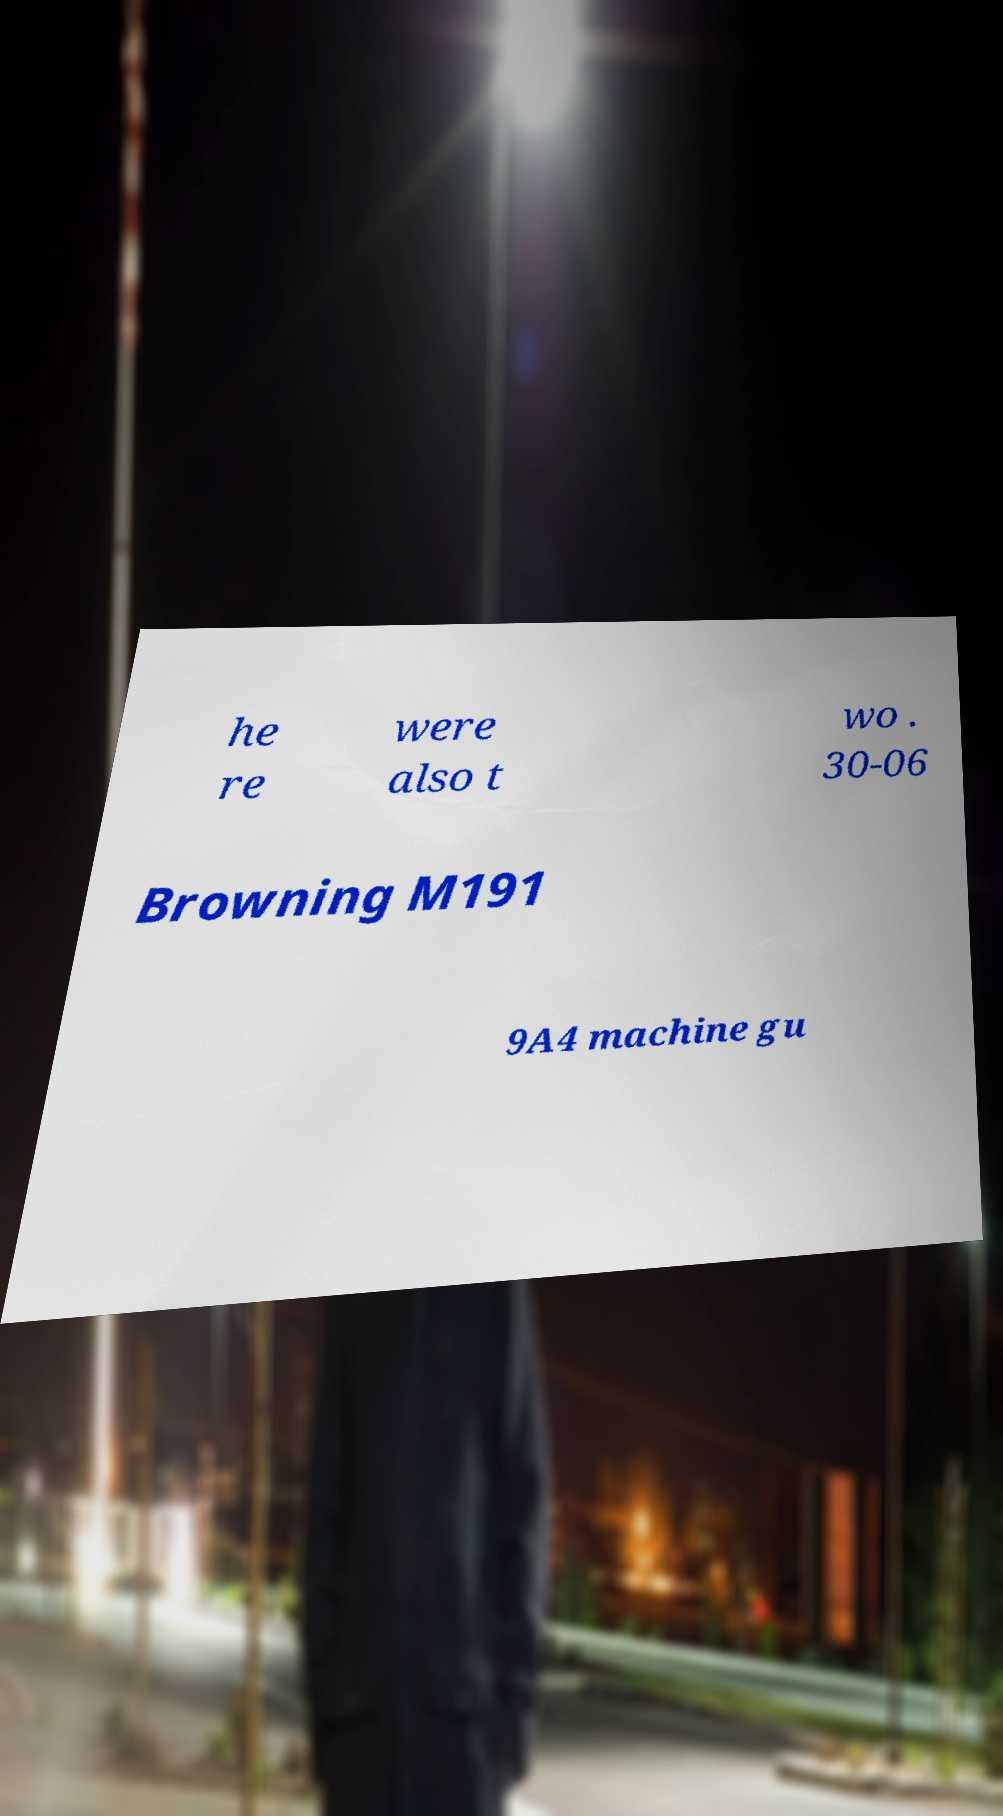There's text embedded in this image that I need extracted. Can you transcribe it verbatim? he re were also t wo . 30-06 Browning M191 9A4 machine gu 